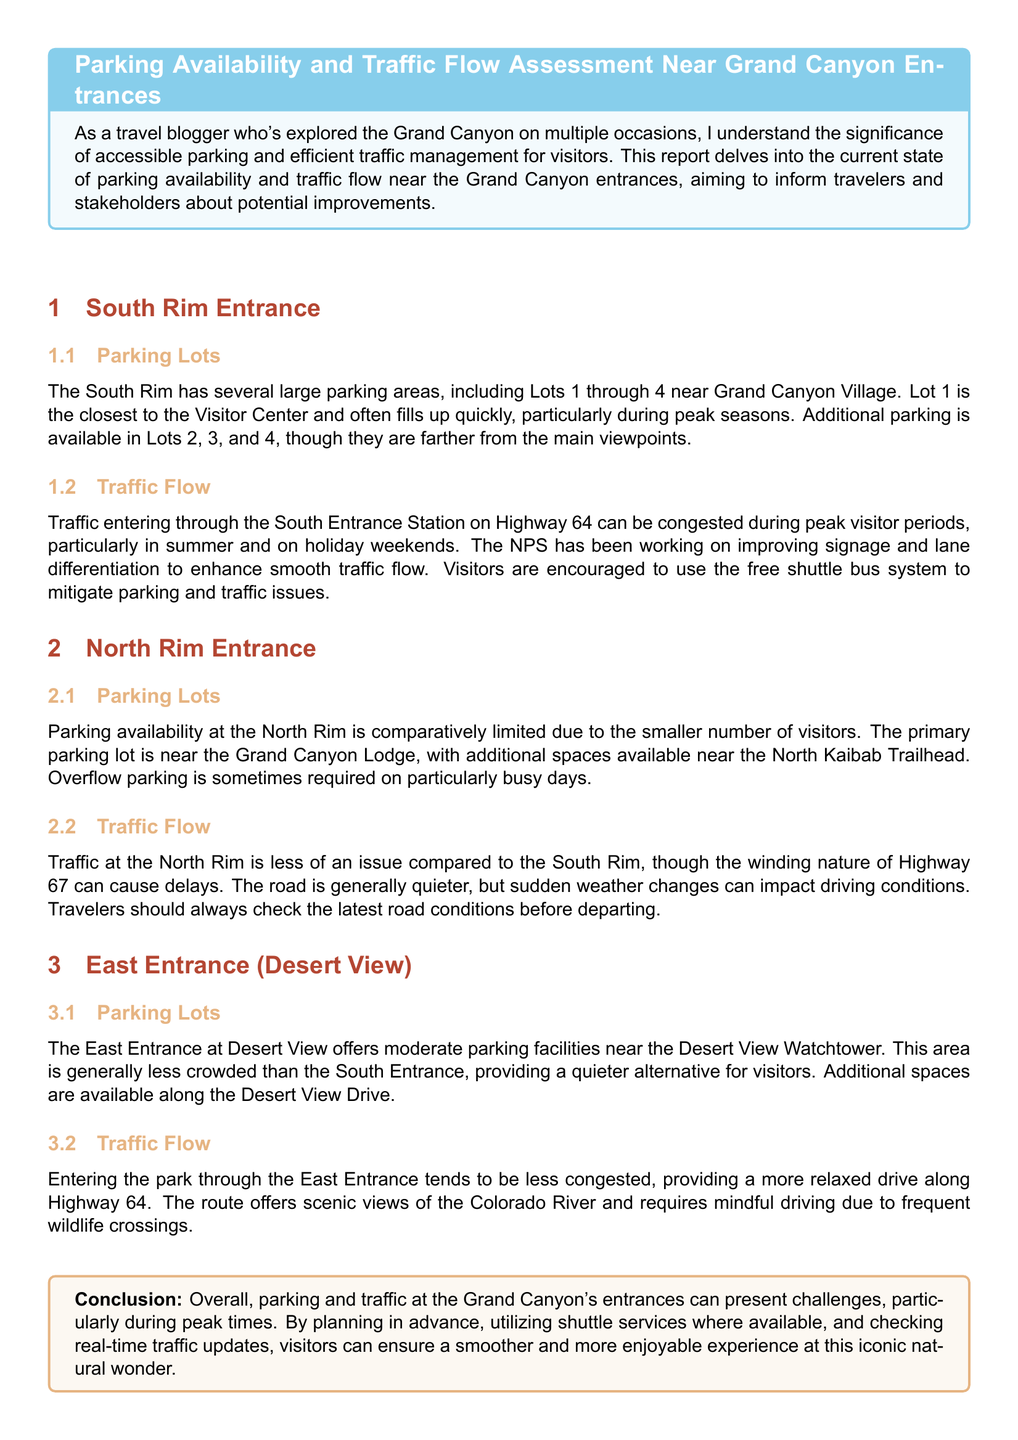What is the name of the primary parking lot at the North Rim? The document states that the primary parking lot is near the Grand Canyon Lodge.
Answer: Grand Canyon Lodge How many parking lots are mentioned at the South Rim? The document lists Lots 1 through 4 at the South Rim, which totals four parking lots.
Answer: 4 What should visitors use to mitigate parking and traffic issues at the South Rim? The text recommends using the free shuttle bus system to help address parking and traffic concerns.
Answer: Free shuttle bus system Which entrance has limited parking availability compared to others? The document specifies that the North Rim has comparatively limited parking availability.
Answer: North Rim What is the typical traffic condition at the East Entrance? According to the document, entering through the East Entrance tends to be less congested.
Answer: Less congested During which periods is traffic congestion more likely at the South Rim? The document mentions that traffic congestion is more likely during peak visitor periods, such as summer and holiday weekends.
Answer: Peak visitor periods What is a potential factor that can affect driving conditions at the North Rim? The document notes that sudden weather changes can impact driving conditions at the North Rim.
Answer: Sudden weather changes Where is overflow parking sometimes required at the North Rim? The text indicates that overflow parking is sometimes needed on particularly busy days near the primary parking lot.
Answer: Near the primary parking lot 